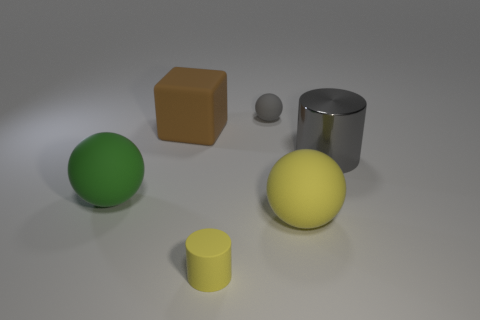Add 2 gray metallic objects. How many objects exist? 8 Subtract all cylinders. How many objects are left? 4 Add 1 small yellow objects. How many small yellow objects exist? 2 Subtract 0 green cubes. How many objects are left? 6 Subtract all cyan cylinders. Subtract all large yellow balls. How many objects are left? 5 Add 6 tiny yellow cylinders. How many tiny yellow cylinders are left? 7 